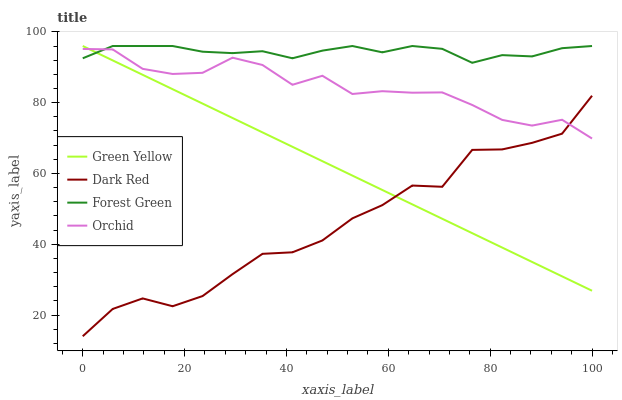Does Dark Red have the minimum area under the curve?
Answer yes or no. Yes. Does Forest Green have the maximum area under the curve?
Answer yes or no. Yes. Does Green Yellow have the minimum area under the curve?
Answer yes or no. No. Does Green Yellow have the maximum area under the curve?
Answer yes or no. No. Is Green Yellow the smoothest?
Answer yes or no. Yes. Is Dark Red the roughest?
Answer yes or no. Yes. Is Forest Green the smoothest?
Answer yes or no. No. Is Forest Green the roughest?
Answer yes or no. No. Does Green Yellow have the lowest value?
Answer yes or no. No. Does Green Yellow have the highest value?
Answer yes or no. Yes. Does Orchid have the highest value?
Answer yes or no. No. Is Dark Red less than Forest Green?
Answer yes or no. Yes. Is Forest Green greater than Dark Red?
Answer yes or no. Yes. Does Forest Green intersect Orchid?
Answer yes or no. Yes. Is Forest Green less than Orchid?
Answer yes or no. No. Is Forest Green greater than Orchid?
Answer yes or no. No. Does Dark Red intersect Forest Green?
Answer yes or no. No. 